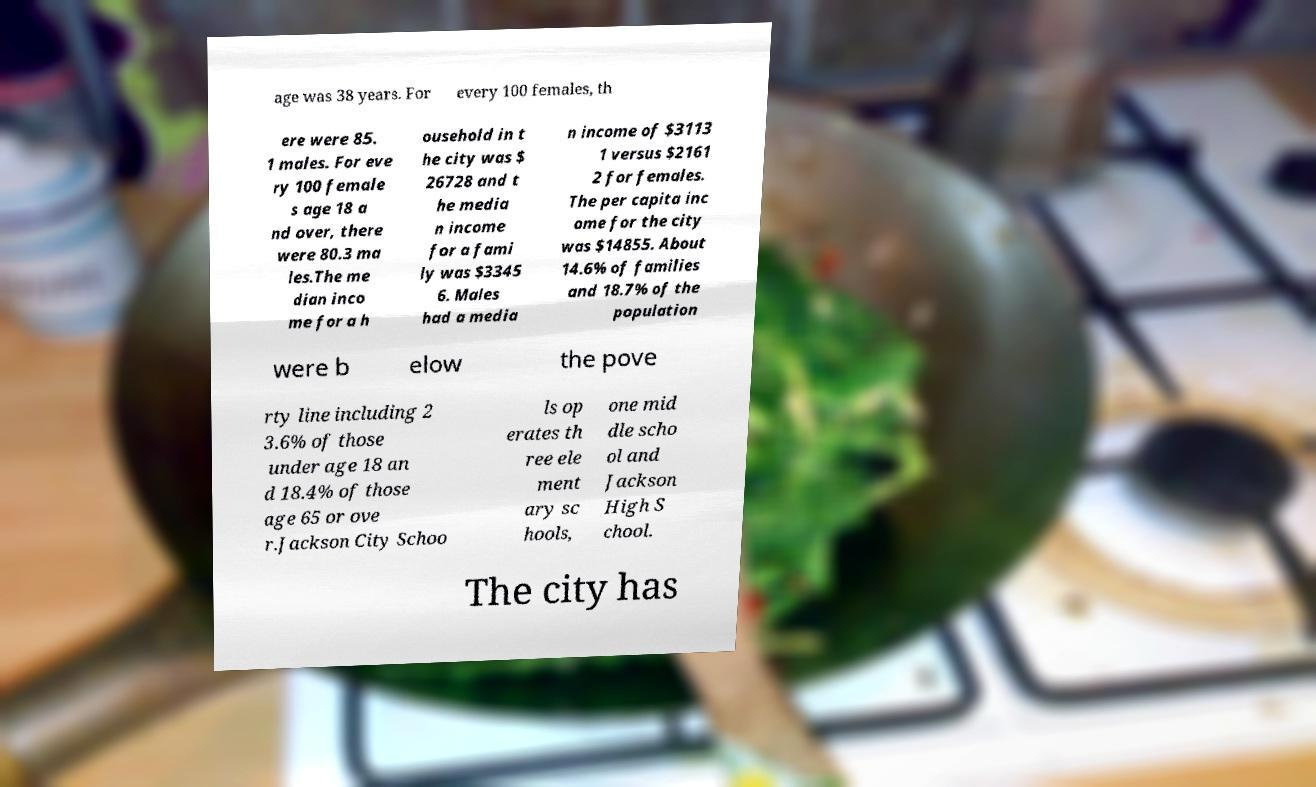Please identify and transcribe the text found in this image. age was 38 years. For every 100 females, th ere were 85. 1 males. For eve ry 100 female s age 18 a nd over, there were 80.3 ma les.The me dian inco me for a h ousehold in t he city was $ 26728 and t he media n income for a fami ly was $3345 6. Males had a media n income of $3113 1 versus $2161 2 for females. The per capita inc ome for the city was $14855. About 14.6% of families and 18.7% of the population were b elow the pove rty line including 2 3.6% of those under age 18 an d 18.4% of those age 65 or ove r.Jackson City Schoo ls op erates th ree ele ment ary sc hools, one mid dle scho ol and Jackson High S chool. The city has 